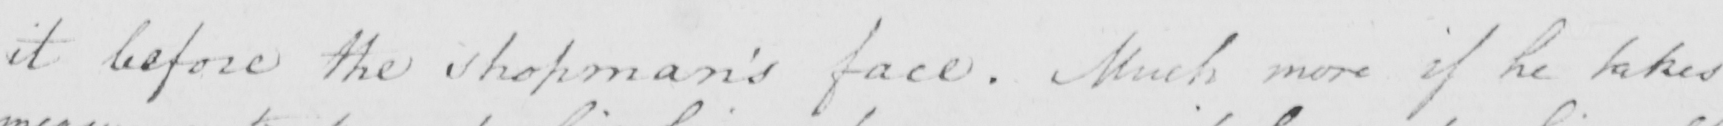What does this handwritten line say? it before the shopman ' s face . Much more if he takes 